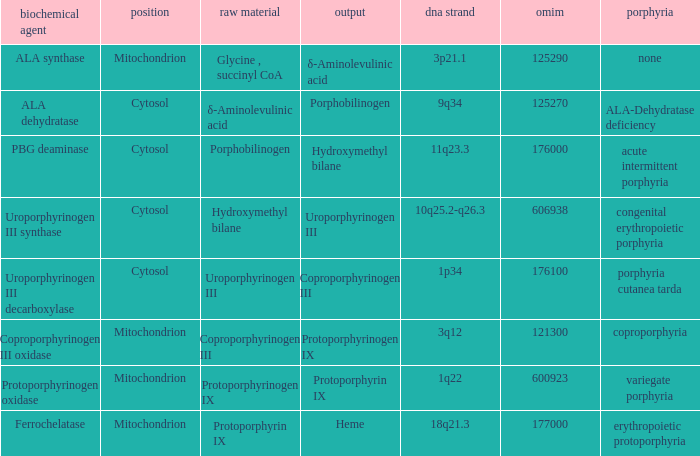Could you help me parse every detail presented in this table? {'header': ['biochemical agent', 'position', 'raw material', 'output', 'dna strand', 'omim', 'porphyria'], 'rows': [['ALA synthase', 'Mitochondrion', 'Glycine , succinyl CoA', 'δ-Aminolevulinic acid', '3p21.1', '125290', 'none'], ['ALA dehydratase', 'Cytosol', 'δ-Aminolevulinic acid', 'Porphobilinogen', '9q34', '125270', 'ALA-Dehydratase deficiency'], ['PBG deaminase', 'Cytosol', 'Porphobilinogen', 'Hydroxymethyl bilane', '11q23.3', '176000', 'acute intermittent porphyria'], ['Uroporphyrinogen III synthase', 'Cytosol', 'Hydroxymethyl bilane', 'Uroporphyrinogen III', '10q25.2-q26.3', '606938', 'congenital erythropoietic porphyria'], ['Uroporphyrinogen III decarboxylase', 'Cytosol', 'Uroporphyrinogen III', 'Coproporphyrinogen III', '1p34', '176100', 'porphyria cutanea tarda'], ['Coproporphyrinogen III oxidase', 'Mitochondrion', 'Coproporphyrinogen III', 'Protoporphyrinogen IX', '3q12', '121300', 'coproporphyria'], ['Protoporphyrinogen oxidase', 'Mitochondrion', 'Protoporphyrinogen IX', 'Protoporphyrin IX', '1q22', '600923', 'variegate porphyria'], ['Ferrochelatase', 'Mitochondrion', 'Protoporphyrin IX', 'Heme', '18q21.3', '177000', 'erythropoietic protoporphyria']]} What is the location of the enzyme Uroporphyrinogen iii Synthase? Cytosol. 